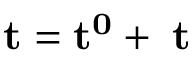<formula> <loc_0><loc_0><loc_500><loc_500>t = t ^ { 0 } + \Delta t</formula> 